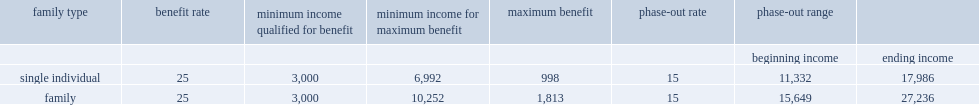In 2014, what is the benefit rate that witb taxpayers would give for every dollar earned above $3,000? 25.0. What is the maximum benefit for single individuals. 998.0. What is the maximum benefit for single individuals. 1813.0. For families, what is the reducing rate for every dollar of income above $15,649, returning to zero for incomes above $27,236. 15.0. 